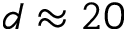Convert formula to latex. <formula><loc_0><loc_0><loc_500><loc_500>d \approx 2 0</formula> 